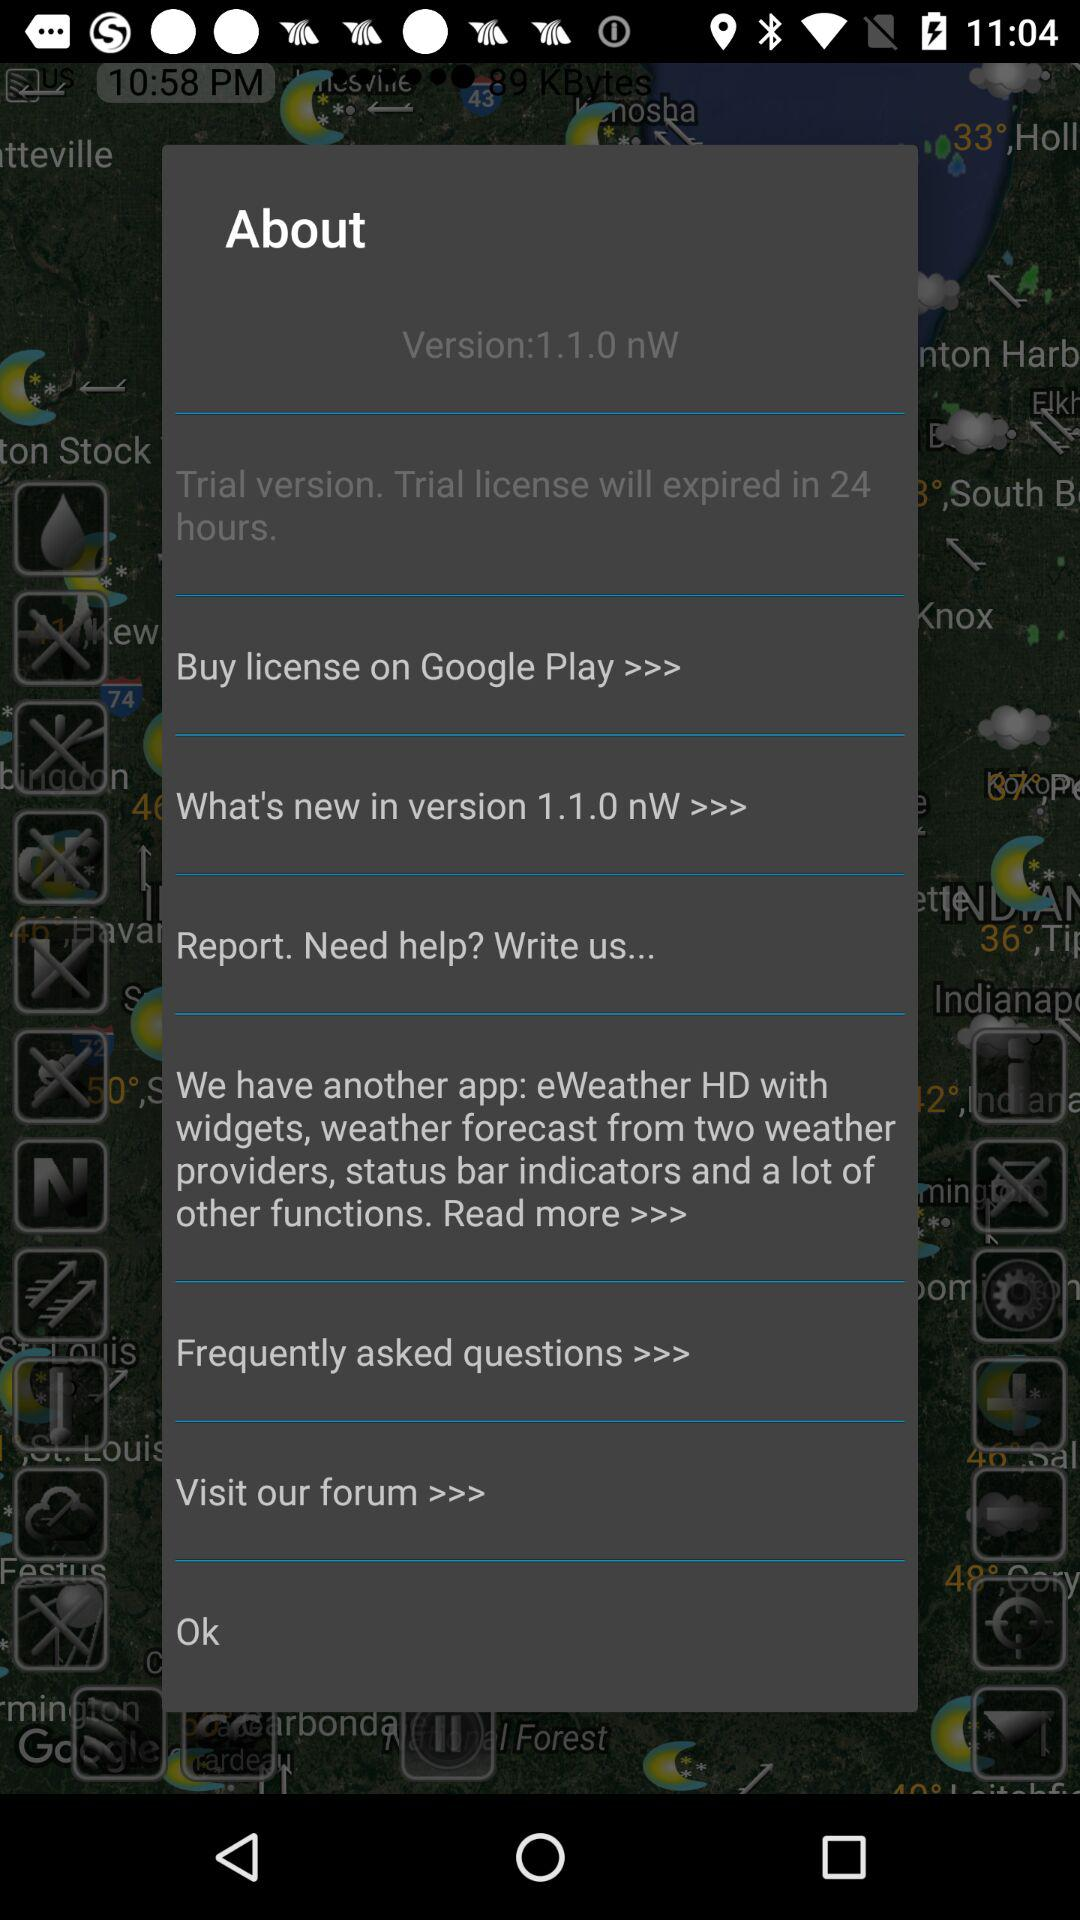What is the time duration of the trial license expiring? The time duration of the trial license expiring is 24 hours. 